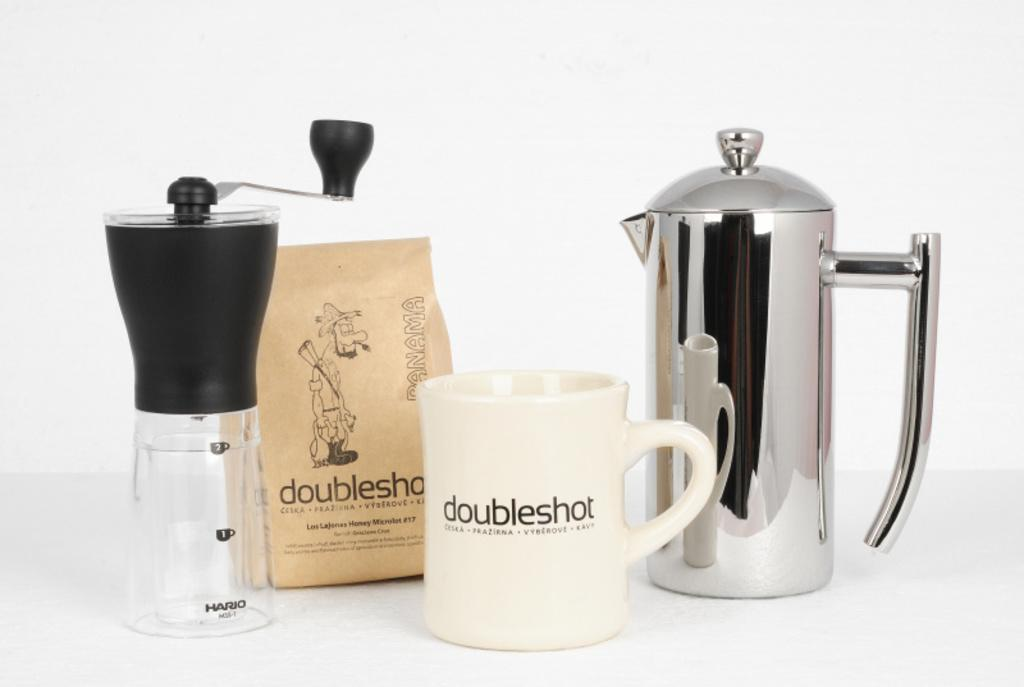<image>
Render a clear and concise summary of the photo. a display of different coffee related items from doubleshot 